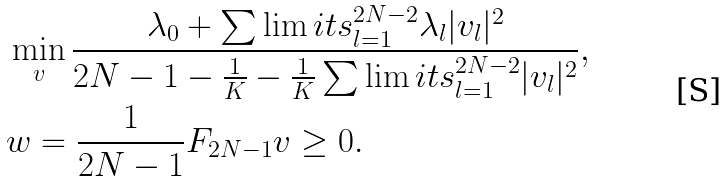Convert formula to latex. <formula><loc_0><loc_0><loc_500><loc_500>& \min _ { v } \frac { \lambda _ { 0 } + \sum \lim i t s _ { l = 1 } ^ { 2 N - 2 } \lambda _ { l } | v _ { l } | ^ { 2 } } { 2 N - 1 - \frac { 1 } { K } - \frac { 1 } { K } \sum \lim i t s _ { l = 1 } ^ { 2 N - 2 } | v _ { l } | ^ { 2 } } , \\ & w = \frac { 1 } { 2 N - 1 } F _ { 2 N - 1 } v \geq 0 .</formula> 